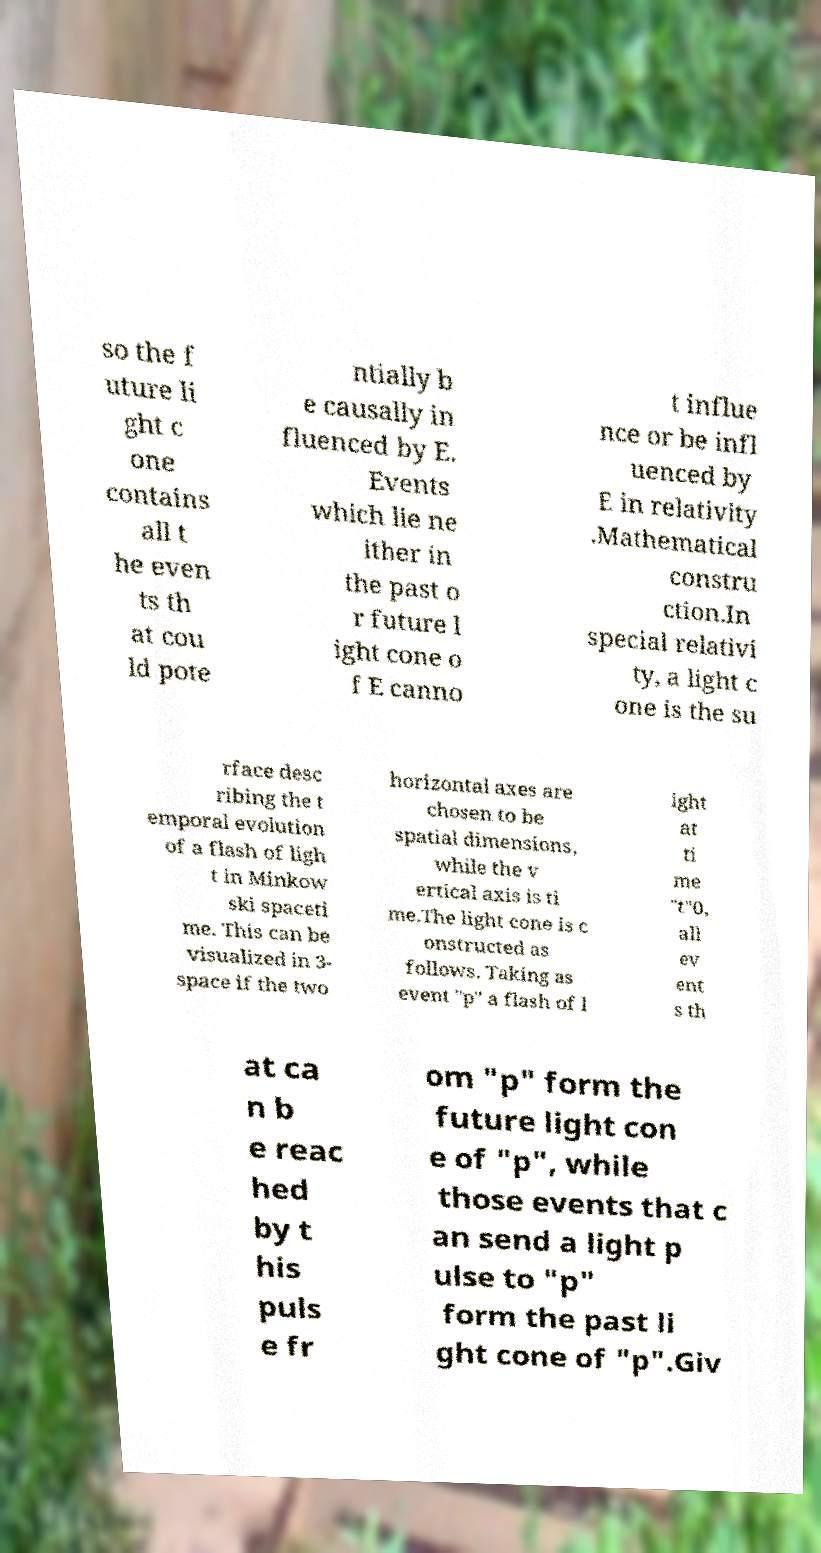Could you assist in decoding the text presented in this image and type it out clearly? so the f uture li ght c one contains all t he even ts th at cou ld pote ntially b e causally in fluenced by E. Events which lie ne ither in the past o r future l ight cone o f E canno t influe nce or be infl uenced by E in relativity .Mathematical constru ction.In special relativi ty, a light c one is the su rface desc ribing the t emporal evolution of a flash of ligh t in Minkow ski spaceti me. This can be visualized in 3- space if the two horizontal axes are chosen to be spatial dimensions, while the v ertical axis is ti me.The light cone is c onstructed as follows. Taking as event "p" a flash of l ight at ti me "t"0, all ev ent s th at ca n b e reac hed by t his puls e fr om "p" form the future light con e of "p", while those events that c an send a light p ulse to "p" form the past li ght cone of "p".Giv 